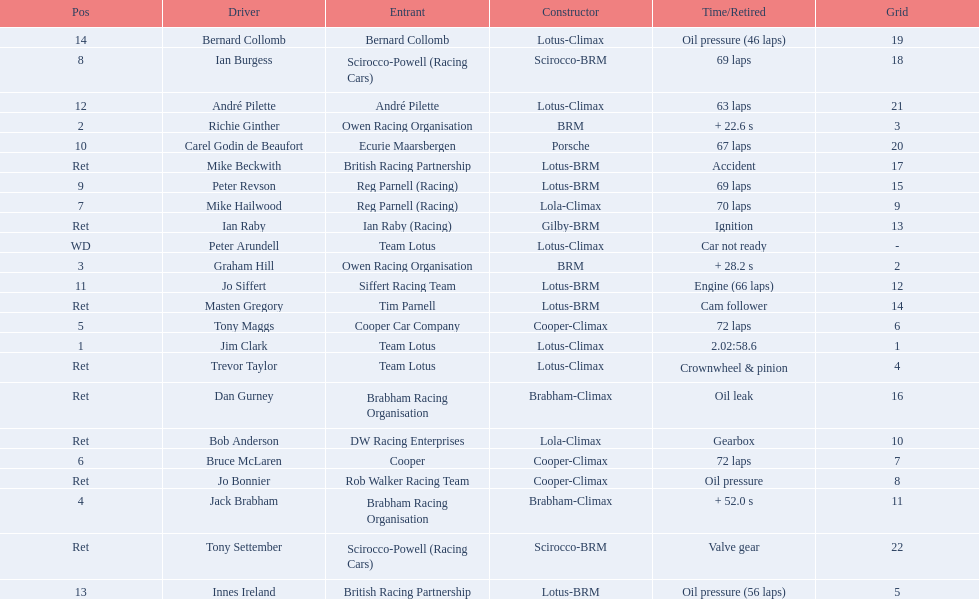Which driver did not have his/her car ready? Peter Arundell. Give me the full table as a dictionary. {'header': ['Pos', 'Driver', 'Entrant', 'Constructor', 'Time/Retired', 'Grid'], 'rows': [['14', 'Bernard Collomb', 'Bernard Collomb', 'Lotus-Climax', 'Oil pressure (46 laps)', '19'], ['8', 'Ian Burgess', 'Scirocco-Powell (Racing Cars)', 'Scirocco-BRM', '69 laps', '18'], ['12', 'André Pilette', 'André Pilette', 'Lotus-Climax', '63 laps', '21'], ['2', 'Richie Ginther', 'Owen Racing Organisation', 'BRM', '+ 22.6 s', '3'], ['10', 'Carel Godin de Beaufort', 'Ecurie Maarsbergen', 'Porsche', '67 laps', '20'], ['Ret', 'Mike Beckwith', 'British Racing Partnership', 'Lotus-BRM', 'Accident', '17'], ['9', 'Peter Revson', 'Reg Parnell (Racing)', 'Lotus-BRM', '69 laps', '15'], ['7', 'Mike Hailwood', 'Reg Parnell (Racing)', 'Lola-Climax', '70 laps', '9'], ['Ret', 'Ian Raby', 'Ian Raby (Racing)', 'Gilby-BRM', 'Ignition', '13'], ['WD', 'Peter Arundell', 'Team Lotus', 'Lotus-Climax', 'Car not ready', '-'], ['3', 'Graham Hill', 'Owen Racing Organisation', 'BRM', '+ 28.2 s', '2'], ['11', 'Jo Siffert', 'Siffert Racing Team', 'Lotus-BRM', 'Engine (66 laps)', '12'], ['Ret', 'Masten Gregory', 'Tim Parnell', 'Lotus-BRM', 'Cam follower', '14'], ['5', 'Tony Maggs', 'Cooper Car Company', 'Cooper-Climax', '72 laps', '6'], ['1', 'Jim Clark', 'Team Lotus', 'Lotus-Climax', '2.02:58.6', '1'], ['Ret', 'Trevor Taylor', 'Team Lotus', 'Lotus-Climax', 'Crownwheel & pinion', '4'], ['Ret', 'Dan Gurney', 'Brabham Racing Organisation', 'Brabham-Climax', 'Oil leak', '16'], ['Ret', 'Bob Anderson', 'DW Racing Enterprises', 'Lola-Climax', 'Gearbox', '10'], ['6', 'Bruce McLaren', 'Cooper', 'Cooper-Climax', '72 laps', '7'], ['Ret', 'Jo Bonnier', 'Rob Walker Racing Team', 'Cooper-Climax', 'Oil pressure', '8'], ['4', 'Jack Brabham', 'Brabham Racing Organisation', 'Brabham-Climax', '+ 52.0 s', '11'], ['Ret', 'Tony Settember', 'Scirocco-Powell (Racing Cars)', 'Scirocco-BRM', 'Valve gear', '22'], ['13', 'Innes Ireland', 'British Racing Partnership', 'Lotus-BRM', 'Oil pressure (56 laps)', '5']]} 